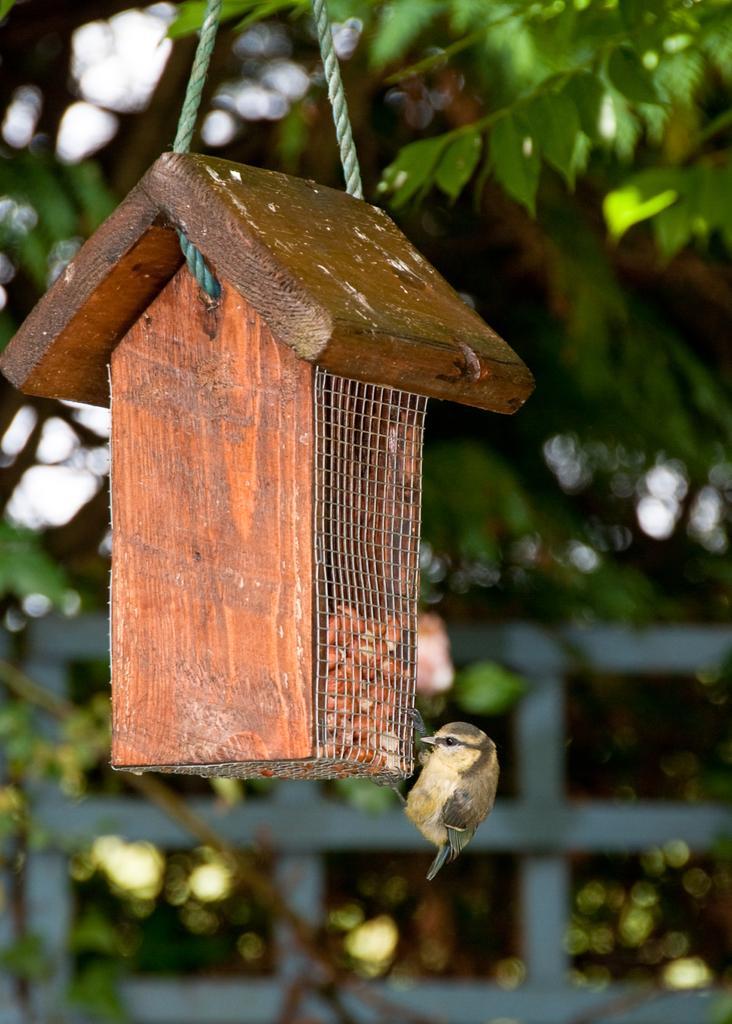Can you describe this image briefly? In this image there is a bird on the birdhouse. In the background of the image there is a metal fence. There are trees. 